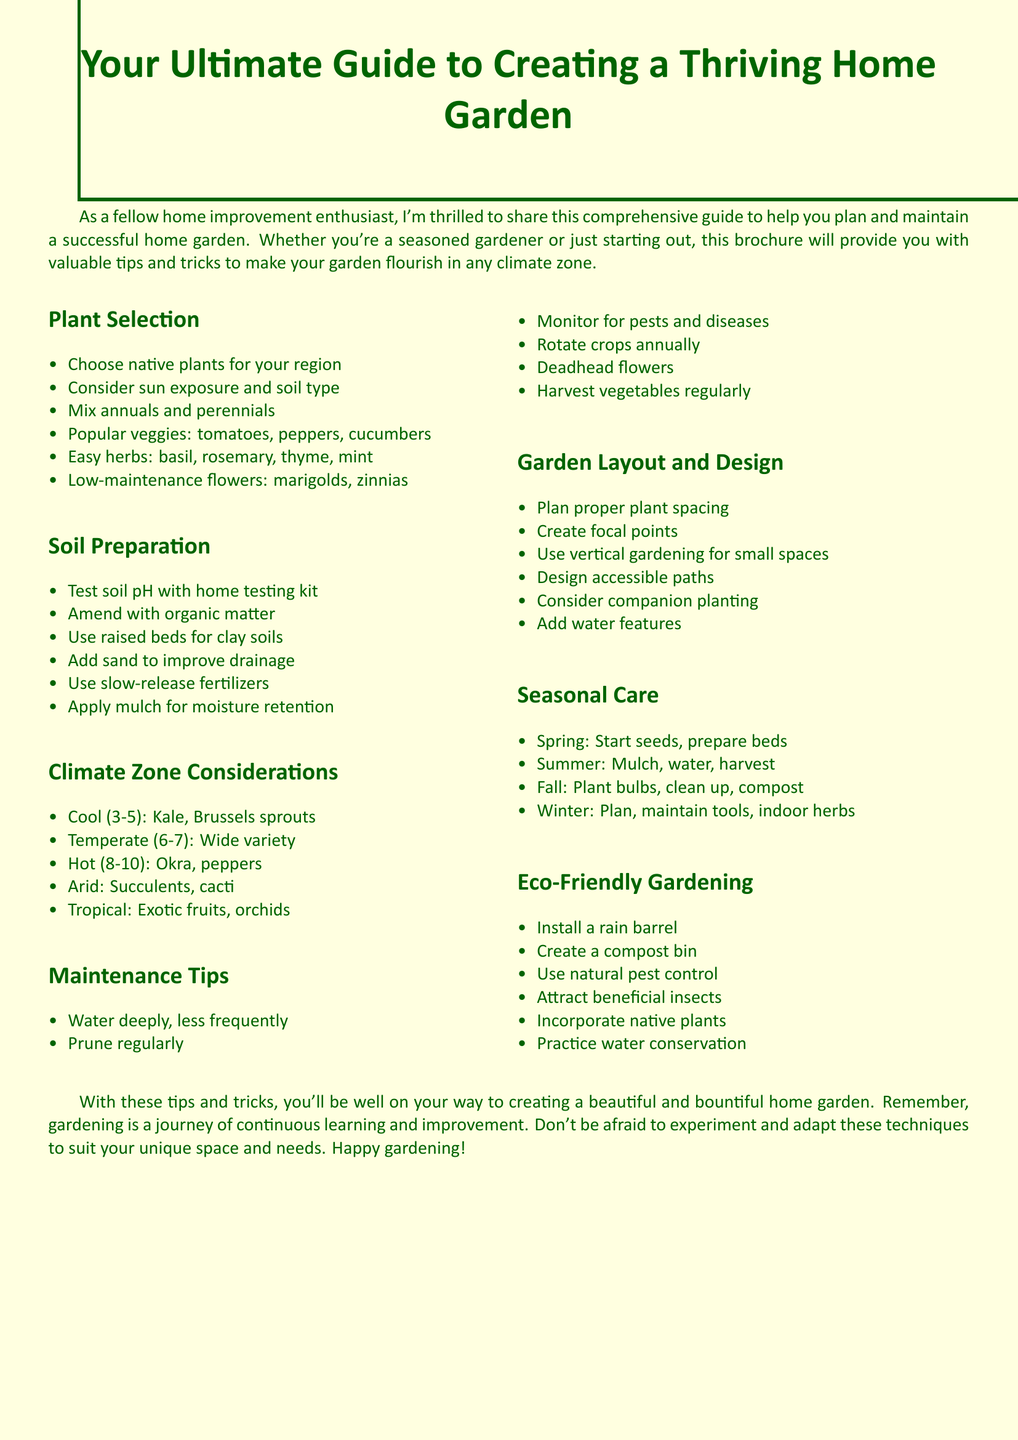What is the title of the brochure? The title is prominently displayed at the top of the brochure.
Answer: Your Ultimate Guide to Creating a Thriving Home Garden Which section discusses the types of plants to grow? This information can be found in the section specifically addressing plant choices.
Answer: Plant Selection Name two easy-to-grow herbs mentioned in the brochure. The brochure lists several herbs and requests a specific example from that list.
Answer: basil, rosemary What should you do in the fall according to the seasonal care section? This information is part of the seasonal tasks outlined in the document.
Answer: Plant bulbs for spring In which climate zones should you focus on cold-hardy plants? The brochure specifies which zones correspond to specific plant types.
Answer: Zones 3-5 What is one method suggested for eco-friendly gardening? The brochure includes various practices within the eco-friendly section.
Answer: Install a rain barrel How often should you water deeply, according to maintenance tips? This detail can be found within the maintenance suggestions for proper watering.
Answer: Less frequently What is one benefit of mixing annuals and perennials? The rationale behind mixing these types of plants can be found in the benefits section.
Answer: Year-round interest 